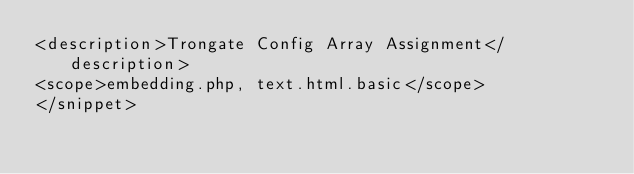<code> <loc_0><loc_0><loc_500><loc_500><_XML_><description>Trongate Config Array Assignment</description>
<scope>embedding.php, text.html.basic</scope>
</snippet></code> 